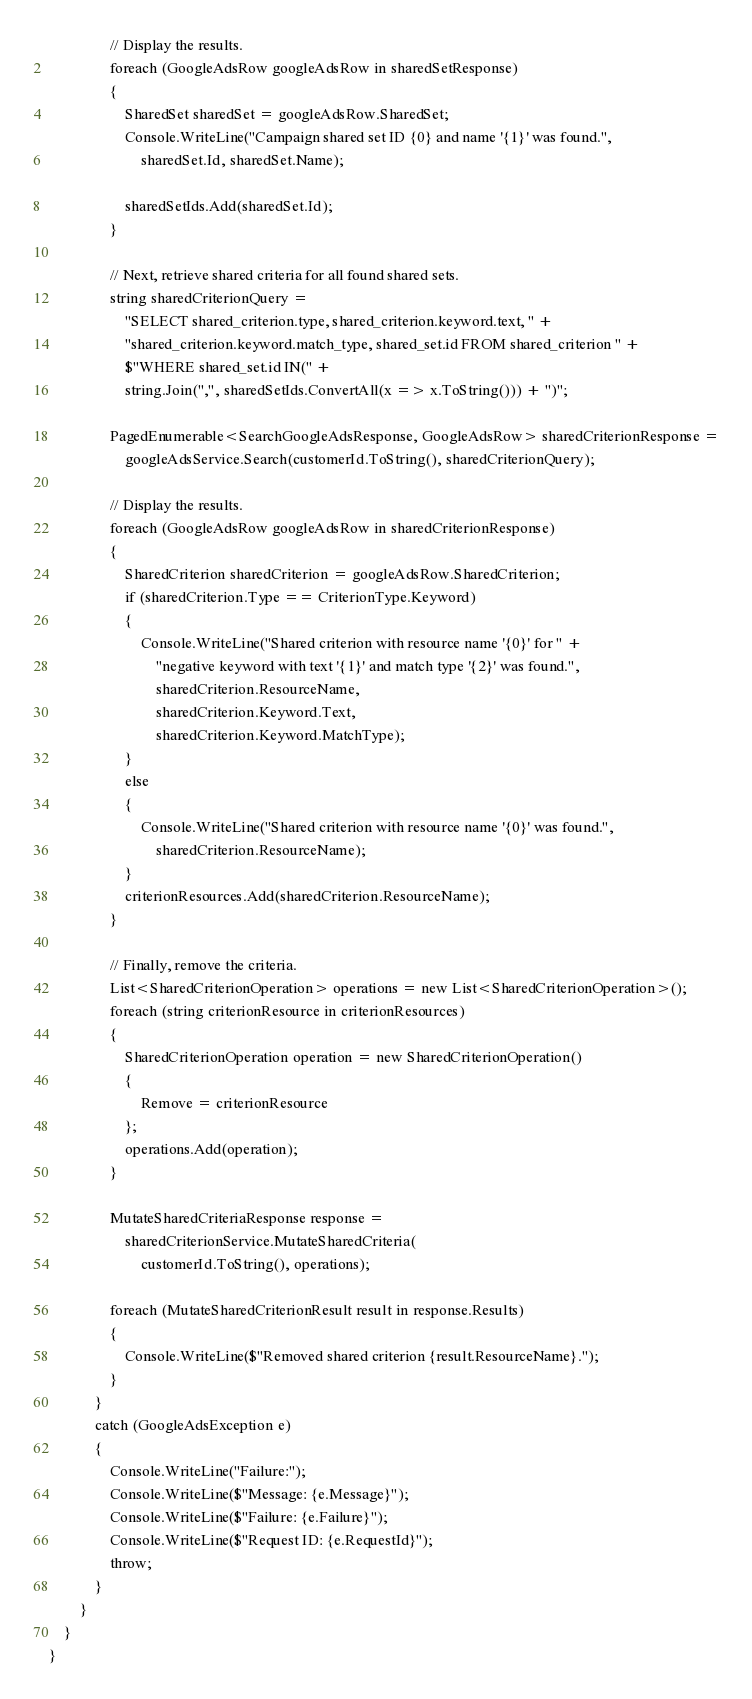Convert code to text. <code><loc_0><loc_0><loc_500><loc_500><_C#_>                // Display the results.
                foreach (GoogleAdsRow googleAdsRow in sharedSetResponse)
                {
                    SharedSet sharedSet = googleAdsRow.SharedSet;
                    Console.WriteLine("Campaign shared set ID {0} and name '{1}' was found.",
                        sharedSet.Id, sharedSet.Name);

                    sharedSetIds.Add(sharedSet.Id);
                }

                // Next, retrieve shared criteria for all found shared sets.
                string sharedCriterionQuery =
                    "SELECT shared_criterion.type, shared_criterion.keyword.text, " +
                    "shared_criterion.keyword.match_type, shared_set.id FROM shared_criterion " +
                    $"WHERE shared_set.id IN(" +
                    string.Join(",", sharedSetIds.ConvertAll(x => x.ToString())) + ")";

                PagedEnumerable<SearchGoogleAdsResponse, GoogleAdsRow> sharedCriterionResponse =
                    googleAdsService.Search(customerId.ToString(), sharedCriterionQuery);

                // Display the results.
                foreach (GoogleAdsRow googleAdsRow in sharedCriterionResponse)
                {
                    SharedCriterion sharedCriterion = googleAdsRow.SharedCriterion;
                    if (sharedCriterion.Type == CriterionType.Keyword)
                    {
                        Console.WriteLine("Shared criterion with resource name '{0}' for " +
                            "negative keyword with text '{1}' and match type '{2}' was found.",
                            sharedCriterion.ResourceName,
                            sharedCriterion.Keyword.Text,
                            sharedCriterion.Keyword.MatchType);
                    }
                    else
                    {
                        Console.WriteLine("Shared criterion with resource name '{0}' was found.",
                            sharedCriterion.ResourceName);
                    }
                    criterionResources.Add(sharedCriterion.ResourceName);
                }

                // Finally, remove the criteria.
                List<SharedCriterionOperation> operations = new List<SharedCriterionOperation>();
                foreach (string criterionResource in criterionResources)
                {
                    SharedCriterionOperation operation = new SharedCriterionOperation()
                    {
                        Remove = criterionResource
                    };
                    operations.Add(operation);
                }

                MutateSharedCriteriaResponse response =
                    sharedCriterionService.MutateSharedCriteria(
                        customerId.ToString(), operations);

                foreach (MutateSharedCriterionResult result in response.Results)
                {
                    Console.WriteLine($"Removed shared criterion {result.ResourceName}.");
                }
            }
            catch (GoogleAdsException e)
            {
                Console.WriteLine("Failure:");
                Console.WriteLine($"Message: {e.Message}");
                Console.WriteLine($"Failure: {e.Failure}");
                Console.WriteLine($"Request ID: {e.RequestId}");
                throw;
            }
        }
    }
}
</code> 